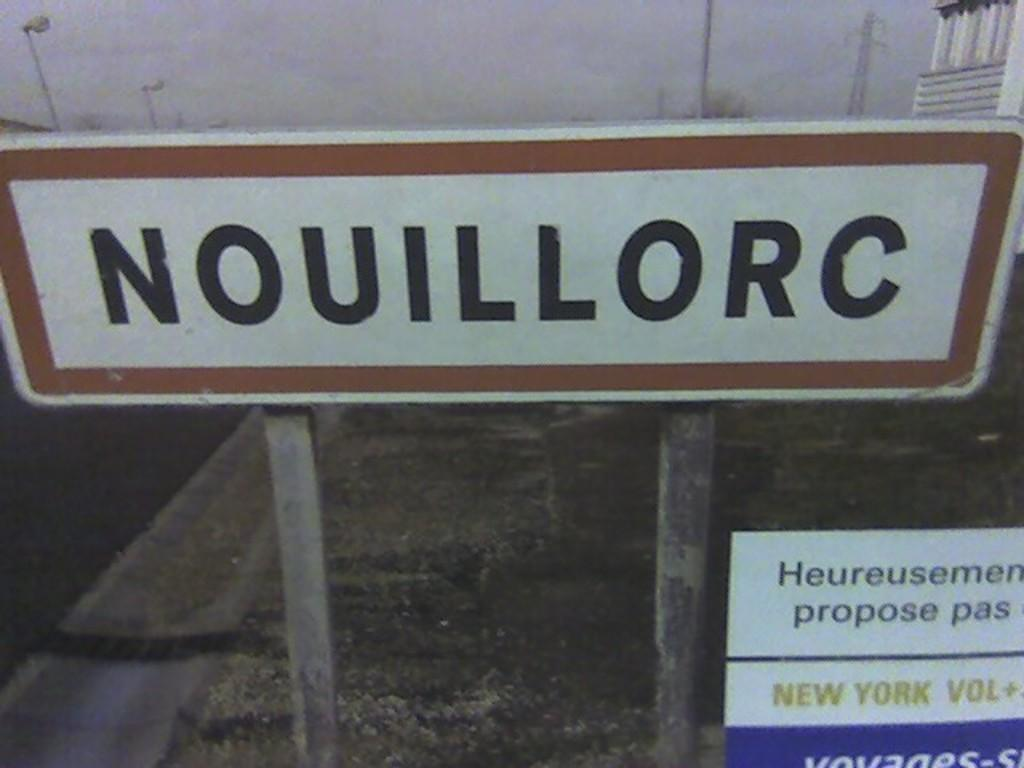<image>
Describe the image concisely. street sign that reads nouillorc looks to be from over seas 